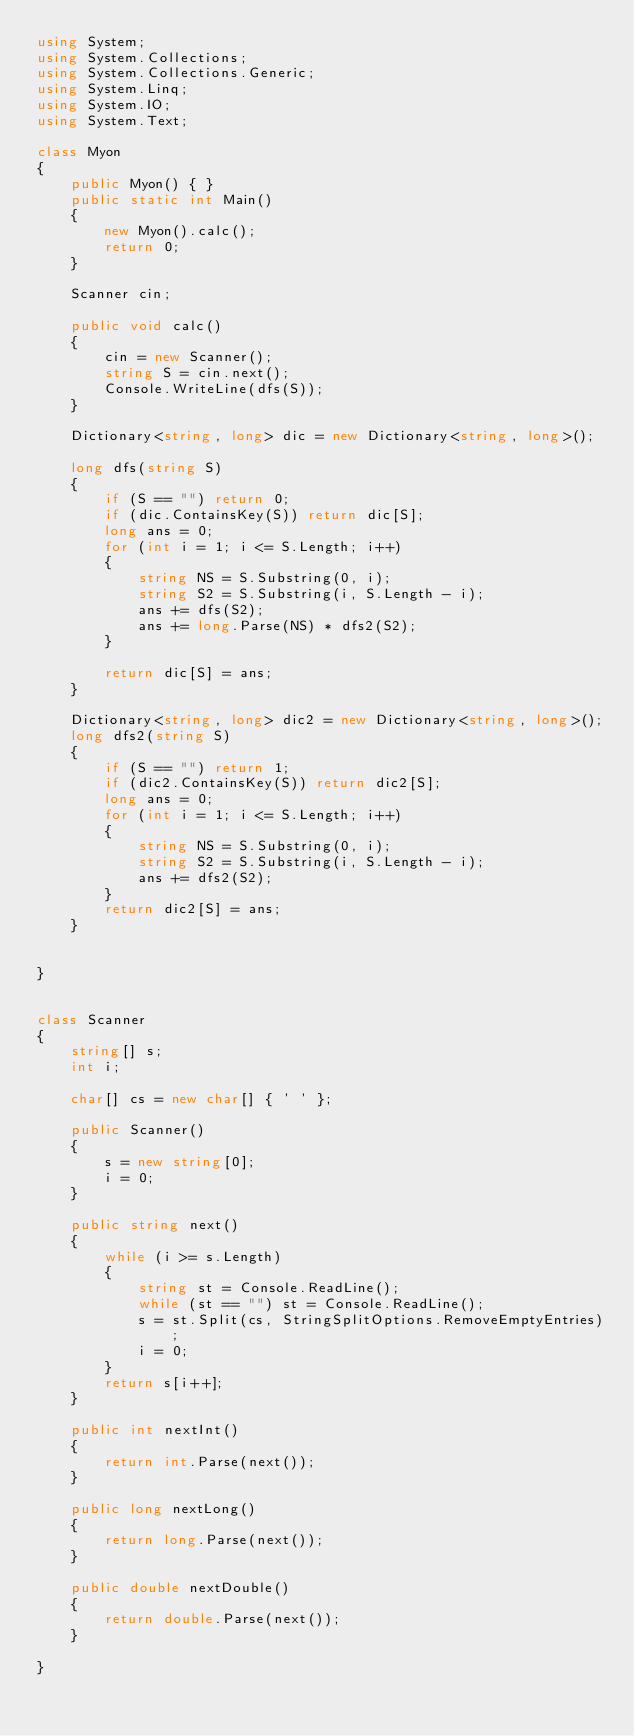Convert code to text. <code><loc_0><loc_0><loc_500><loc_500><_C#_>using System;
using System.Collections;
using System.Collections.Generic;
using System.Linq;
using System.IO;
using System.Text;

class Myon
{
    public Myon() { }
    public static int Main()
    {
        new Myon().calc();
        return 0;
    }

    Scanner cin;

    public void calc()
    {
        cin = new Scanner();
        string S = cin.next();
        Console.WriteLine(dfs(S));
    }

    Dictionary<string, long> dic = new Dictionary<string, long>();

    long dfs(string S)
    {
        if (S == "") return 0;
        if (dic.ContainsKey(S)) return dic[S];
        long ans = 0;
        for (int i = 1; i <= S.Length; i++)
        {
            string NS = S.Substring(0, i);
            string S2 = S.Substring(i, S.Length - i);
            ans += dfs(S2);
            ans += long.Parse(NS) * dfs2(S2);
        }

        return dic[S] = ans;
    }

    Dictionary<string, long> dic2 = new Dictionary<string, long>();
    long dfs2(string S)
    {
        if (S == "") return 1;
        if (dic2.ContainsKey(S)) return dic2[S];
        long ans = 0;
        for (int i = 1; i <= S.Length; i++)
        {
            string NS = S.Substring(0, i);
            string S2 = S.Substring(i, S.Length - i);
            ans += dfs2(S2);
        }
        return dic2[S] = ans;
    }
    

}


class Scanner
{
    string[] s;
    int i;

    char[] cs = new char[] { ' ' };

    public Scanner()
    {
        s = new string[0];
        i = 0;
    }

    public string next()
    {
        while (i >= s.Length)
        {
            string st = Console.ReadLine();
            while (st == "") st = Console.ReadLine();
            s = st.Split(cs, StringSplitOptions.RemoveEmptyEntries);
            i = 0;
        }
        return s[i++];
    }

    public int nextInt()
    {
        return int.Parse(next());
    }

    public long nextLong()
    {
        return long.Parse(next());
    }

    public double nextDouble()
    {
        return double.Parse(next());
    }

}</code> 